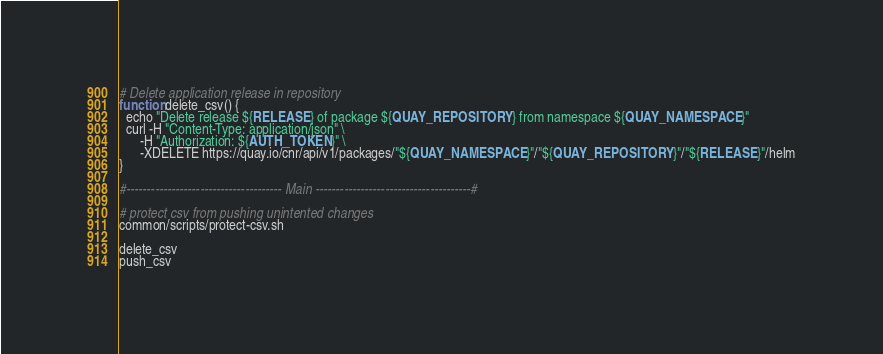Convert code to text. <code><loc_0><loc_0><loc_500><loc_500><_Bash_># Delete application release in repository
function delete_csv() {
  echo "Delete release ${RELEASE} of package ${QUAY_REPOSITORY} from namespace ${QUAY_NAMESPACE}"
  curl -H "Content-Type: application/json" \
      -H "Authorization: ${AUTH_TOKEN}" \
      -XDELETE https://quay.io/cnr/api/v1/packages/"${QUAY_NAMESPACE}"/"${QUAY_REPOSITORY}"/"${RELEASE}"/helm
}

#-------------------------------------- Main --------------------------------------#

# protect csv from pushing unintented changes
common/scripts/protect-csv.sh

delete_csv
push_csv
</code> 